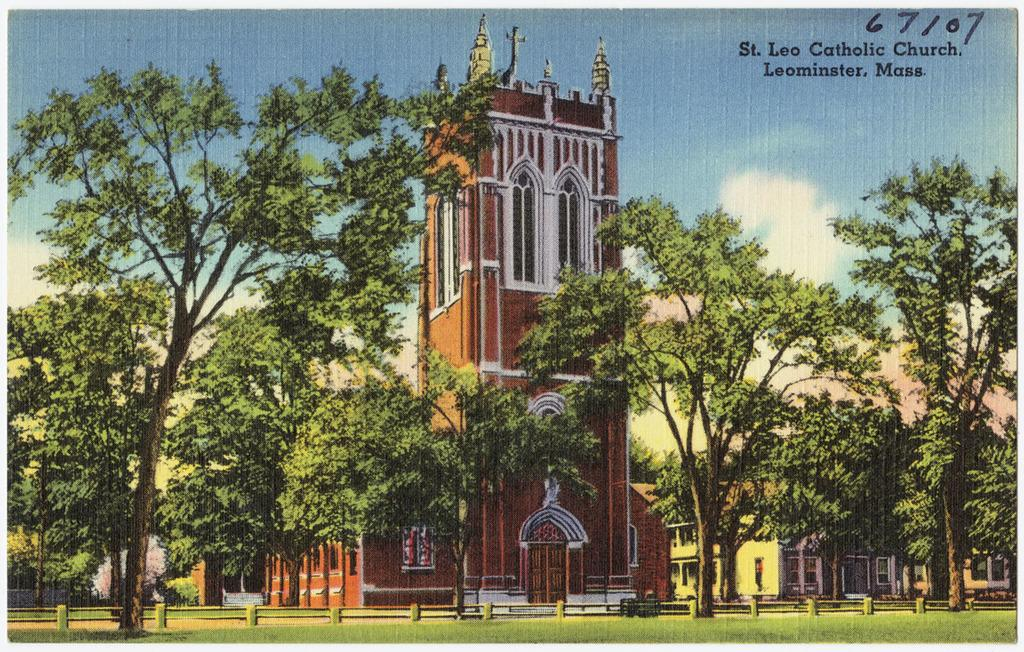<image>
Present a compact description of the photo's key features. A photo of a church with the location Leominster, Mass. at the top. 